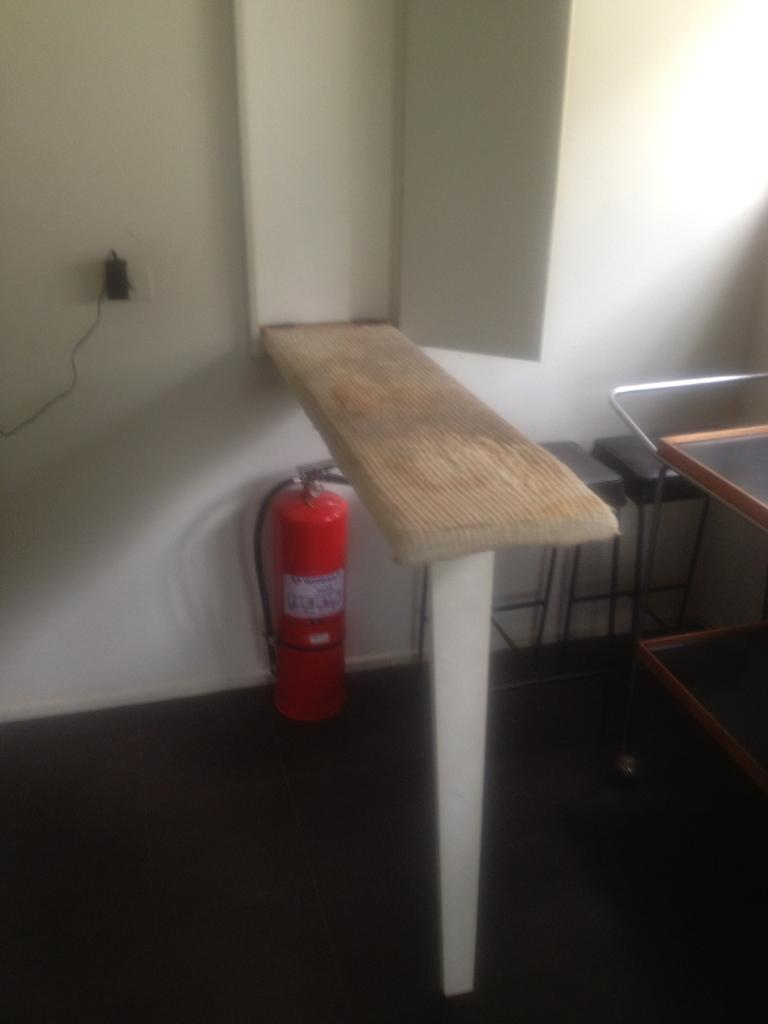What safety device is visible in the image? There is a fire extinguisher in the image. What can be seen on the wall in the background of the image? There is a switch board on the wall in the background of the image. What type of notebook is being used by the mom in the image? There is no mom or notebook present in the image. How many nails are visible in the image? There are no nails visible in the image. 